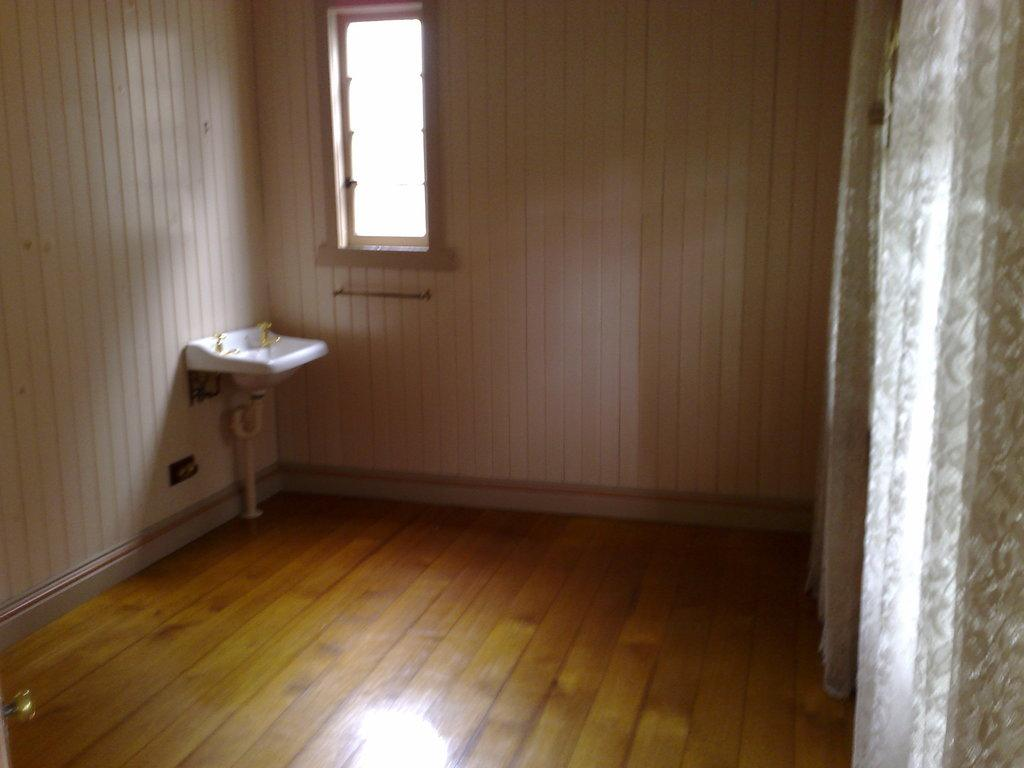What is the general appearance of the room in the image? The room is empty. What is the only visible fixture in the room? There is a wash basin in the room. Where is the wash basin located in relation to other features in the room? The wash basin is located beside a window. What type of wall is present in the background of the room? The background of the room includes a wooden wall. What is the purpose of the big curtain in the room? The big curtain is located beside the wooden wall, but its purpose is not specified in the image. What type of structure is being served for dinner in the image? There is no dinner or structure present in the image; it only features an empty room with a wash basin, a window, a wooden wall, and a big curtain. How many ducks are visible in the image? There are no ducks present in the image. 